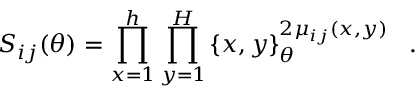<formula> <loc_0><loc_0><loc_500><loc_500>S _ { i j } ( \theta ) = \prod _ { x = 1 } ^ { h } \prod _ { y = 1 } ^ { H } \left \{ x , y \right \} _ { \theta } ^ { 2 \mu _ { i j } ( x , y ) } \, .</formula> 